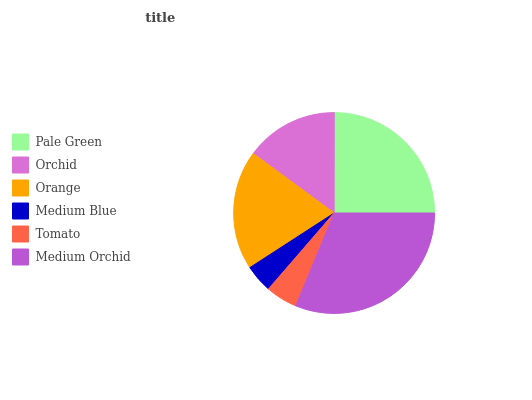Is Medium Blue the minimum?
Answer yes or no. Yes. Is Medium Orchid the maximum?
Answer yes or no. Yes. Is Orchid the minimum?
Answer yes or no. No. Is Orchid the maximum?
Answer yes or no. No. Is Pale Green greater than Orchid?
Answer yes or no. Yes. Is Orchid less than Pale Green?
Answer yes or no. Yes. Is Orchid greater than Pale Green?
Answer yes or no. No. Is Pale Green less than Orchid?
Answer yes or no. No. Is Orange the high median?
Answer yes or no. Yes. Is Orchid the low median?
Answer yes or no. Yes. Is Orchid the high median?
Answer yes or no. No. Is Pale Green the low median?
Answer yes or no. No. 